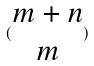<formula> <loc_0><loc_0><loc_500><loc_500>( \begin{matrix} m + n \\ m \end{matrix} )</formula> 